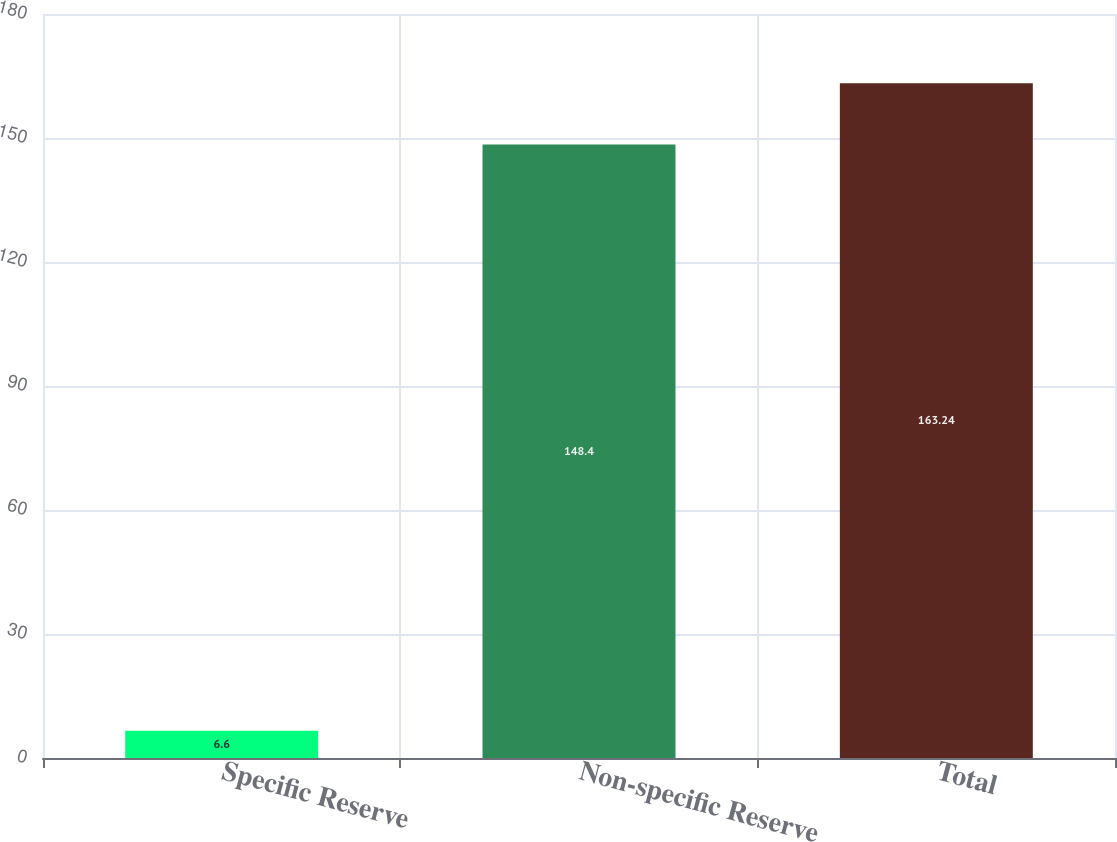<chart> <loc_0><loc_0><loc_500><loc_500><bar_chart><fcel>Specific Reserve<fcel>Non-specific Reserve<fcel>Total<nl><fcel>6.6<fcel>148.4<fcel>163.24<nl></chart> 